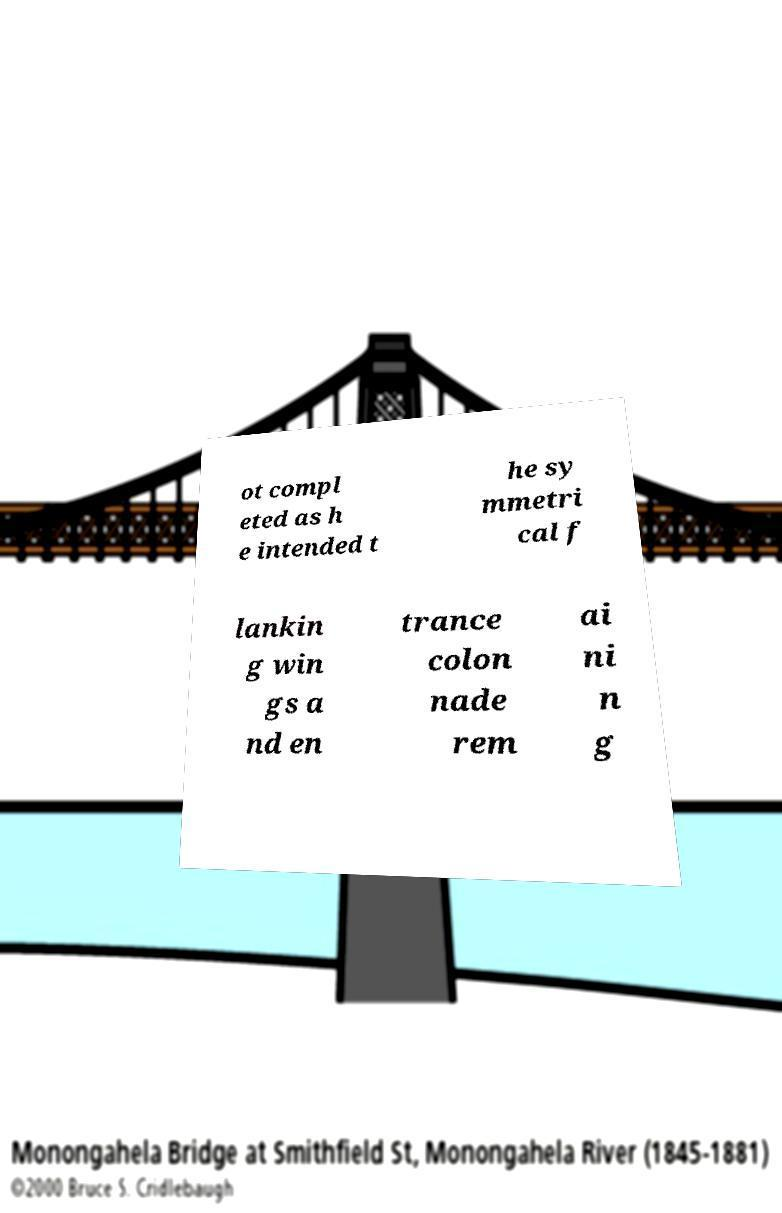I need the written content from this picture converted into text. Can you do that? ot compl eted as h e intended t he sy mmetri cal f lankin g win gs a nd en trance colon nade rem ai ni n g 